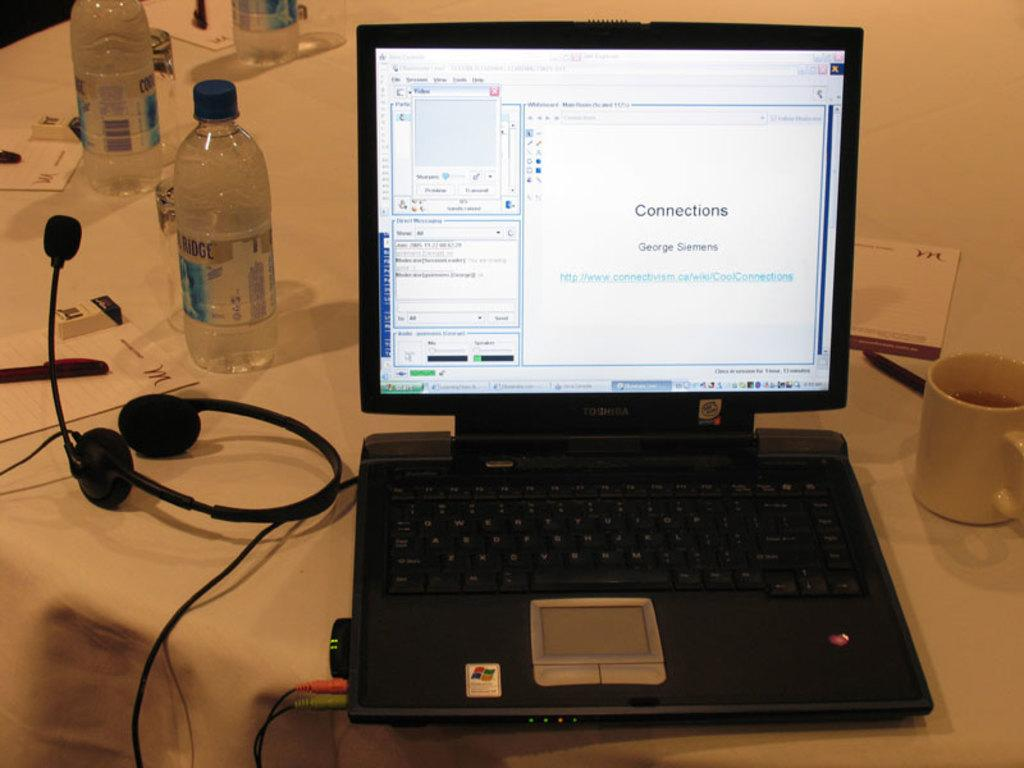What electronic device is visible in the image? There is a laptop in the image. What type of container is present in the image? There is a cup in the image. What type of writing material is in the image? There is a pen in the image. What type of object is used for communication in the image? There is a headset in the image. What type of object is used for writing in the image? There is a paper in the image. On what surface are the objects placed in the image? The objects are on a table in the image. What type of metal is used to make the waves in the image? There are no waves or metal present in the image. What type of paper is used to make the paper airplane in the image? There is no paper airplane present in the image. 